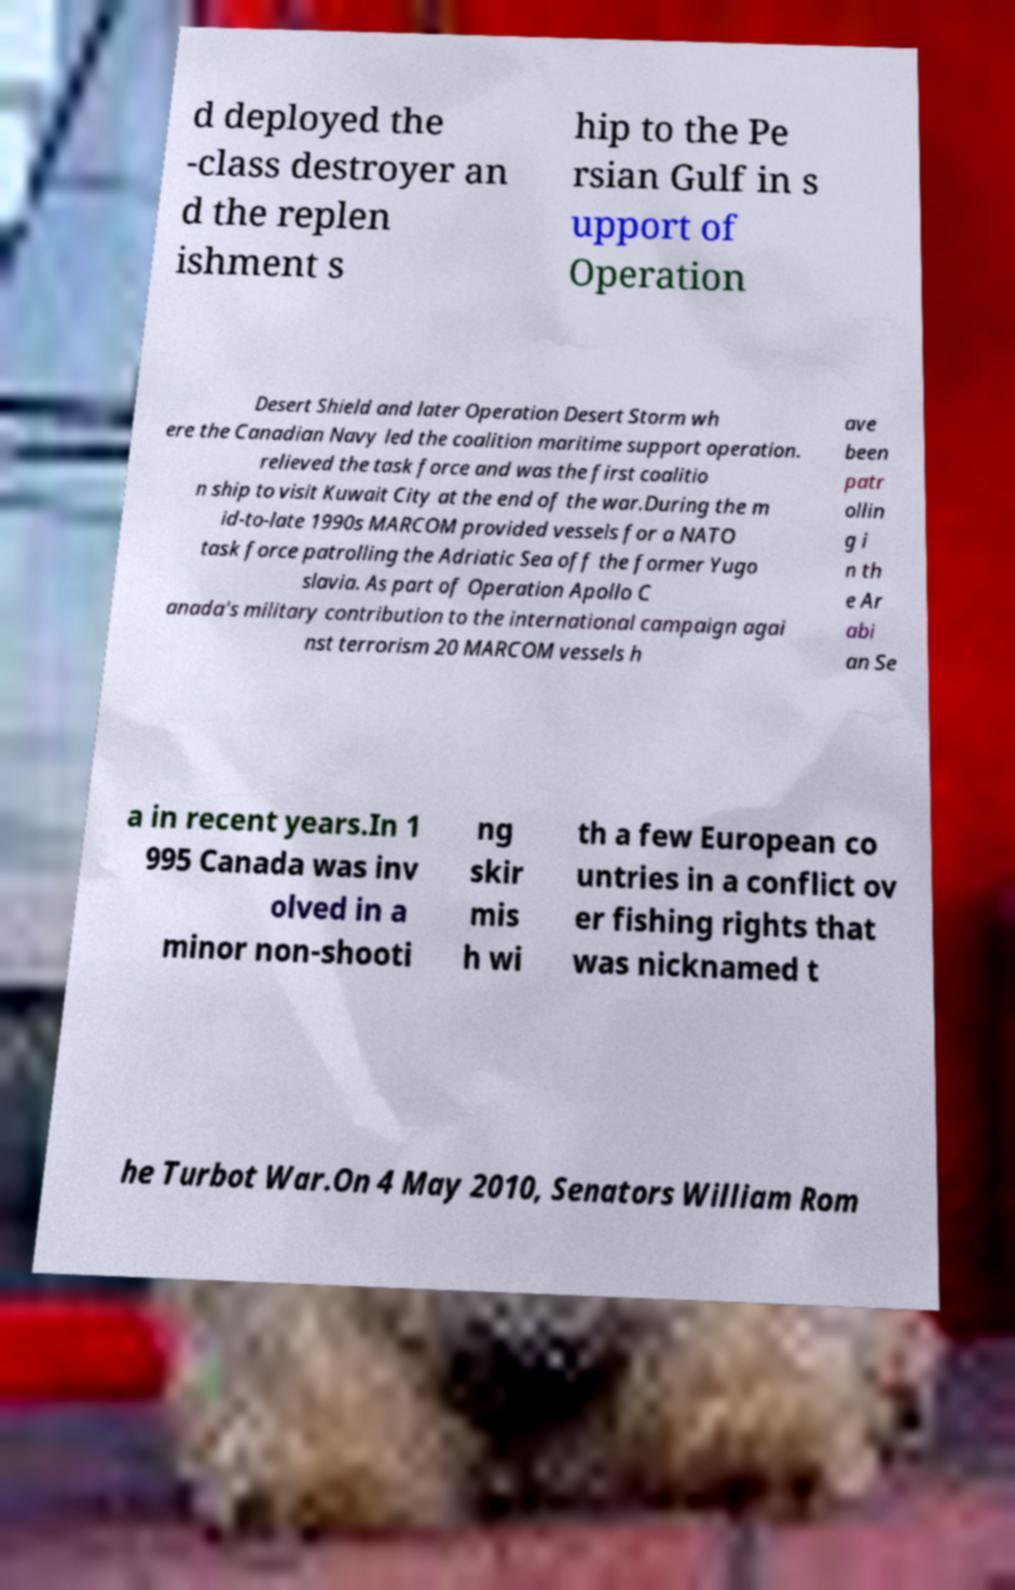Could you assist in decoding the text presented in this image and type it out clearly? d deployed the -class destroyer an d the replen ishment s hip to the Pe rsian Gulf in s upport of Operation Desert Shield and later Operation Desert Storm wh ere the Canadian Navy led the coalition maritime support operation. relieved the task force and was the first coalitio n ship to visit Kuwait City at the end of the war.During the m id-to-late 1990s MARCOM provided vessels for a NATO task force patrolling the Adriatic Sea off the former Yugo slavia. As part of Operation Apollo C anada's military contribution to the international campaign agai nst terrorism 20 MARCOM vessels h ave been patr ollin g i n th e Ar abi an Se a in recent years.In 1 995 Canada was inv olved in a minor non-shooti ng skir mis h wi th a few European co untries in a conflict ov er fishing rights that was nicknamed t he Turbot War.On 4 May 2010, Senators William Rom 